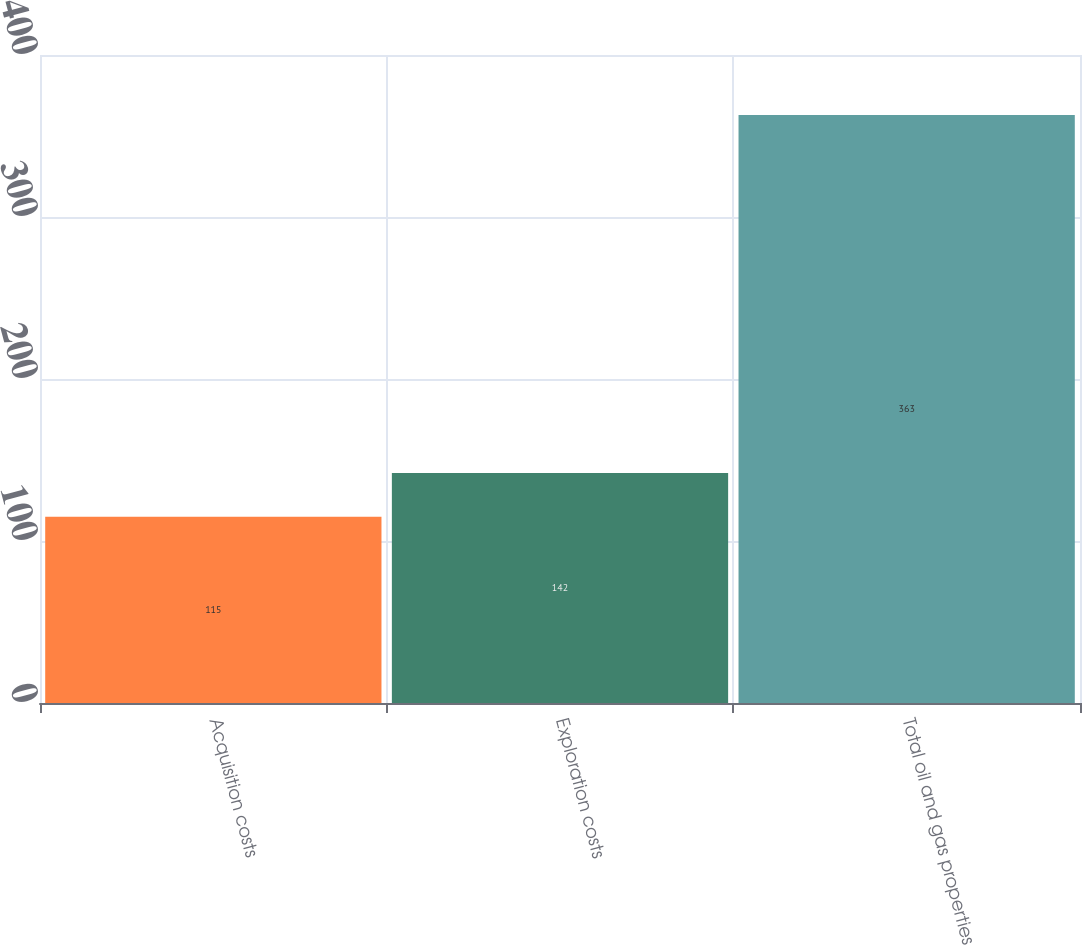Convert chart. <chart><loc_0><loc_0><loc_500><loc_500><bar_chart><fcel>Acquisition costs<fcel>Exploration costs<fcel>Total oil and gas properties<nl><fcel>115<fcel>142<fcel>363<nl></chart> 